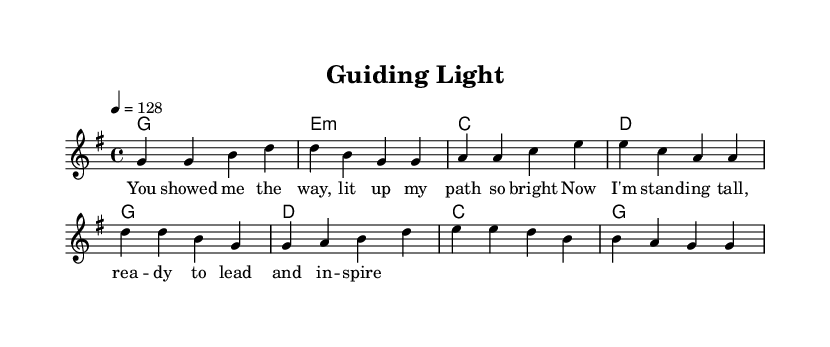What is the key signature of this music? The key signature shown at the beginning is G major, which has one sharp (F#).
Answer: G major What is the time signature of the piece? The time signature is depicted as 4/4, indicating four beats per measure.
Answer: 4/4 What is the tempo indicated in the sheet music? The tempo marking indicates a speed of 128 beats per minute, shown as "4 = 128".
Answer: 128 How many measures are in the verse section? By counting the measures notated in the melody for the verse, there are four measures.
Answer: 4 What is the chord progression for the verse? The harmonies for the verse follow the progression outlined: G, E minor, C, D.
Answer: G, E minor, C, D What is the thematic focus of the lyrics in the song? The lyrics emphasize inspiration and guidance, celebrating mentorship and leadership.
Answer: Inspiration and guidance What genre uniquely characterizes this piece? The characteristics of the music, such as the upbeat rhythm and instrumentation, indicate it belongs to the country rock genre.
Answer: Country rock 